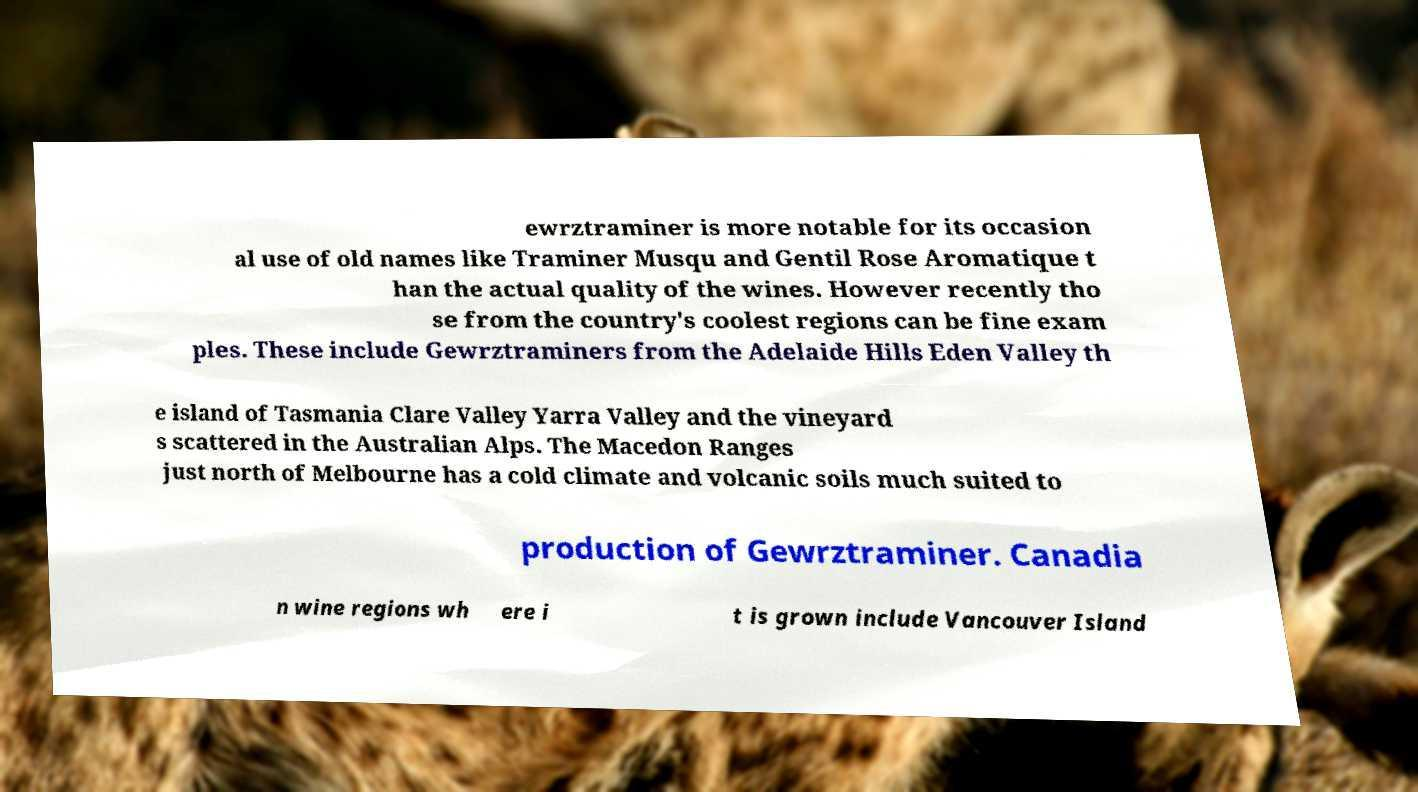Please read and relay the text visible in this image. What does it say? ewrztraminer is more notable for its occasion al use of old names like Traminer Musqu and Gentil Rose Aromatique t han the actual quality of the wines. However recently tho se from the country's coolest regions can be fine exam ples. These include Gewrztraminers from the Adelaide Hills Eden Valley th e island of Tasmania Clare Valley Yarra Valley and the vineyard s scattered in the Australian Alps. The Macedon Ranges just north of Melbourne has a cold climate and volcanic soils much suited to production of Gewrztraminer. Canadia n wine regions wh ere i t is grown include Vancouver Island 